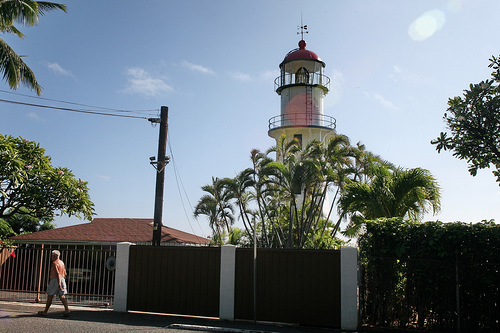<image>What kind of building is this? I'm not sure about the exact typology of the building. It could possibly be a lighthouse or a tower. What kind of building is this? I don't know what kind of building is this. It can be a lighthouse, lookout or tower. 